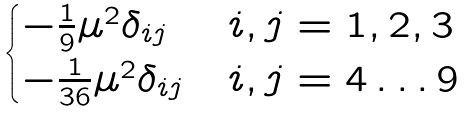Convert formula to latex. <formula><loc_0><loc_0><loc_500><loc_500>\begin{cases} - \frac { 1 } { 9 } \mu ^ { 2 } \delta _ { i j } & i , j = 1 , 2 , 3 \\ - \frac { 1 } { 3 6 } \mu ^ { 2 } \delta _ { i j } & i , j = 4 \dots 9 \end{cases}</formula> 